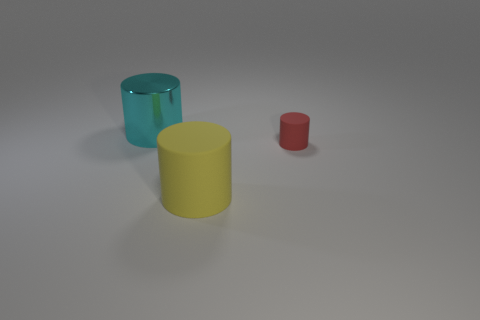Add 2 big cyan objects. How many objects exist? 5 Subtract 0 blue blocks. How many objects are left? 3 Subtract all matte objects. Subtract all tiny purple shiny cylinders. How many objects are left? 1 Add 3 small red cylinders. How many small red cylinders are left? 4 Add 2 big metal cylinders. How many big metal cylinders exist? 3 